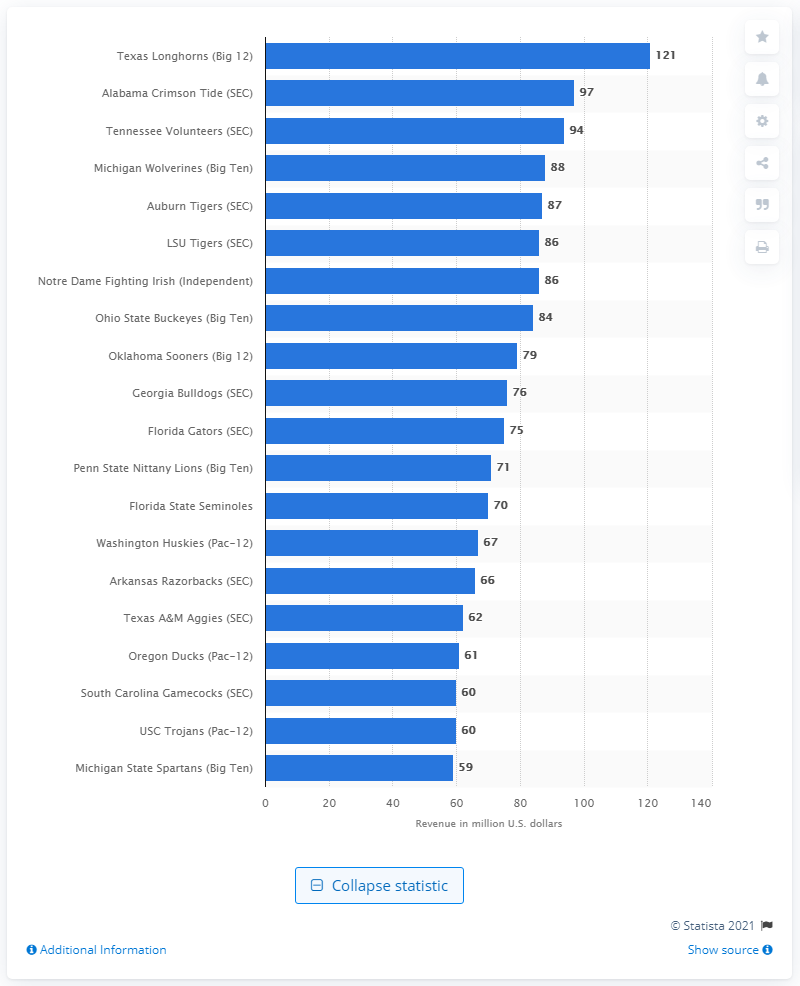Draw attention to some important aspects in this diagram. In 2014, the total revenue of the Notre Dame Fighting Irish football team was 86.. 